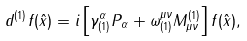Convert formula to latex. <formula><loc_0><loc_0><loc_500><loc_500>d ^ { ( 1 ) } f ( \hat { x } ) = i \left [ \gamma ^ { \alpha } _ { ( 1 ) } P _ { \alpha } + \omega ^ { \mu \nu } _ { ( 1 ) } M _ { \mu \nu } ^ { ( 1 ) } \right ] f ( \hat { x } ) ,</formula> 